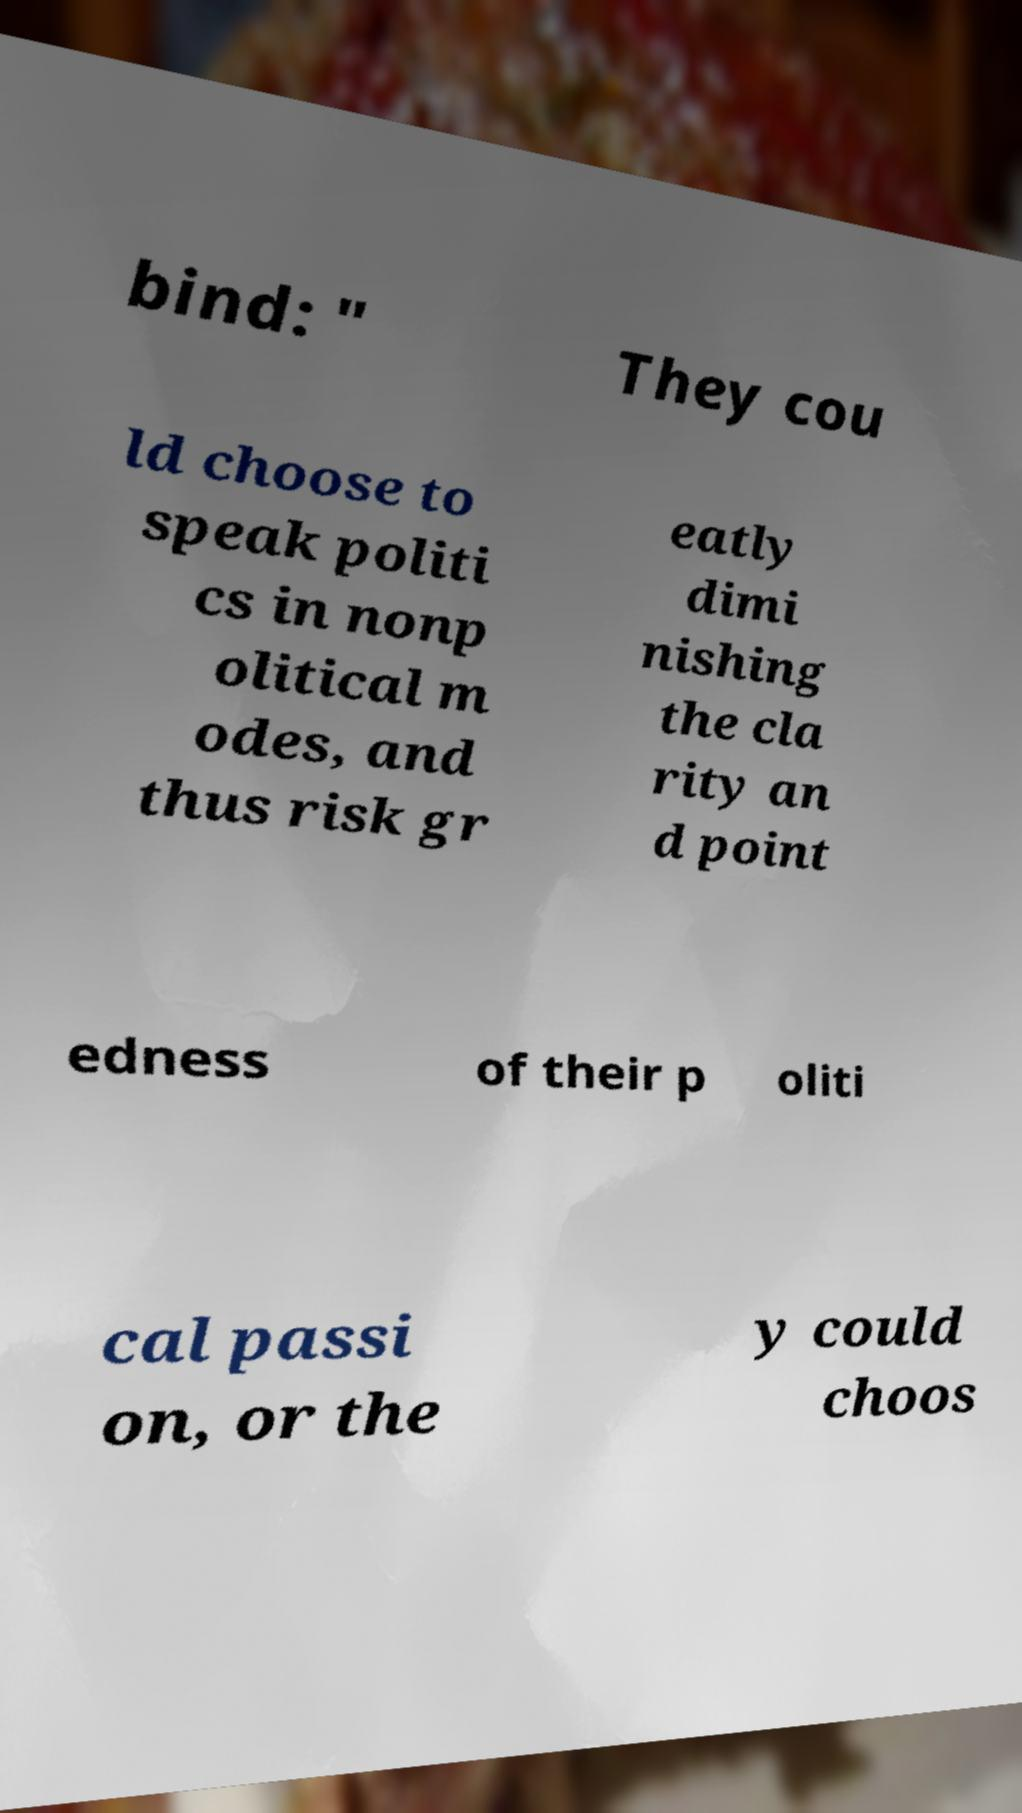There's text embedded in this image that I need extracted. Can you transcribe it verbatim? bind: " They cou ld choose to speak politi cs in nonp olitical m odes, and thus risk gr eatly dimi nishing the cla rity an d point edness of their p oliti cal passi on, or the y could choos 